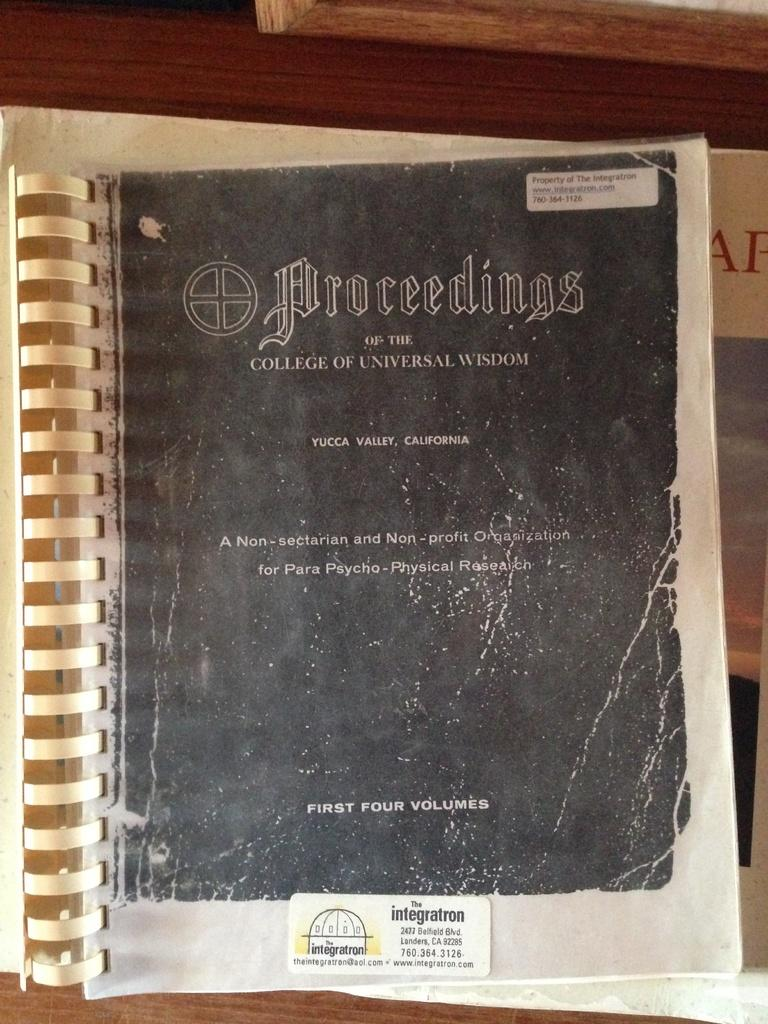<image>
Share a concise interpretation of the image provided. A book on the Proceedings of the College of Universal Wisdom. 